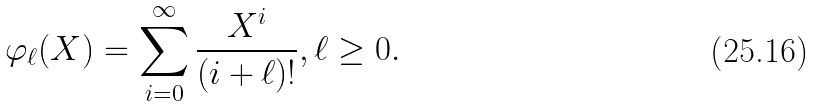Convert formula to latex. <formula><loc_0><loc_0><loc_500><loc_500>\varphi _ { \ell } ( X ) = \sum _ { i = 0 } ^ { \infty } \frac { X ^ { i } } { ( i + \ell ) ! } , \ell \geq 0 .</formula> 